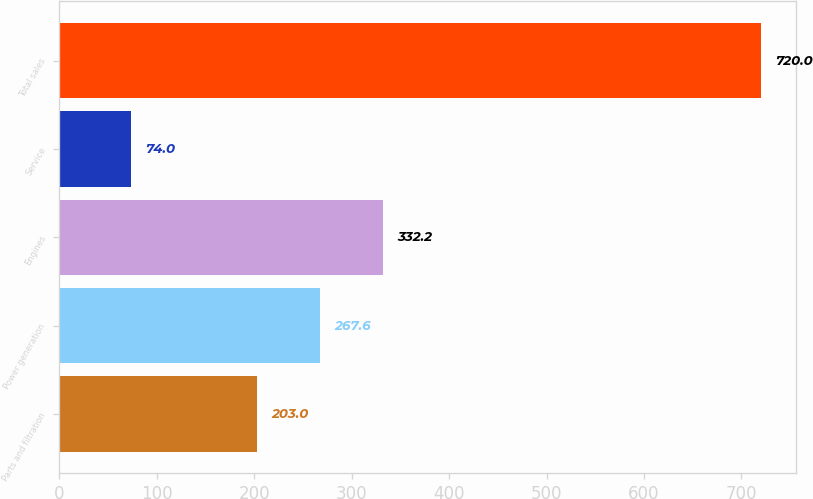<chart> <loc_0><loc_0><loc_500><loc_500><bar_chart><fcel>Parts and filtration<fcel>Power generation<fcel>Engines<fcel>Service<fcel>Total sales<nl><fcel>203<fcel>267.6<fcel>332.2<fcel>74<fcel>720<nl></chart> 